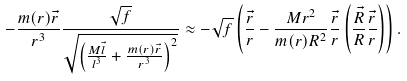Convert formula to latex. <formula><loc_0><loc_0><loc_500><loc_500>- \frac { m ( r ) \vec { r } } { r ^ { 3 } } \frac { \sqrt { f } } { \sqrt { \left ( \frac { M \vec { l } } { l ^ { 3 } } + \frac { m ( r ) \vec { r } } { r ^ { 3 } } \right ) ^ { 2 } } } \approx - \sqrt { f } \left ( \frac { \vec { r } } { r } - \frac { M r ^ { 2 } } { m ( r ) R ^ { 2 } } \frac { \vec { r } } { r } \left ( \frac { \vec { R } } { R } \frac { \vec { r } } { r } \right ) \right ) .</formula> 